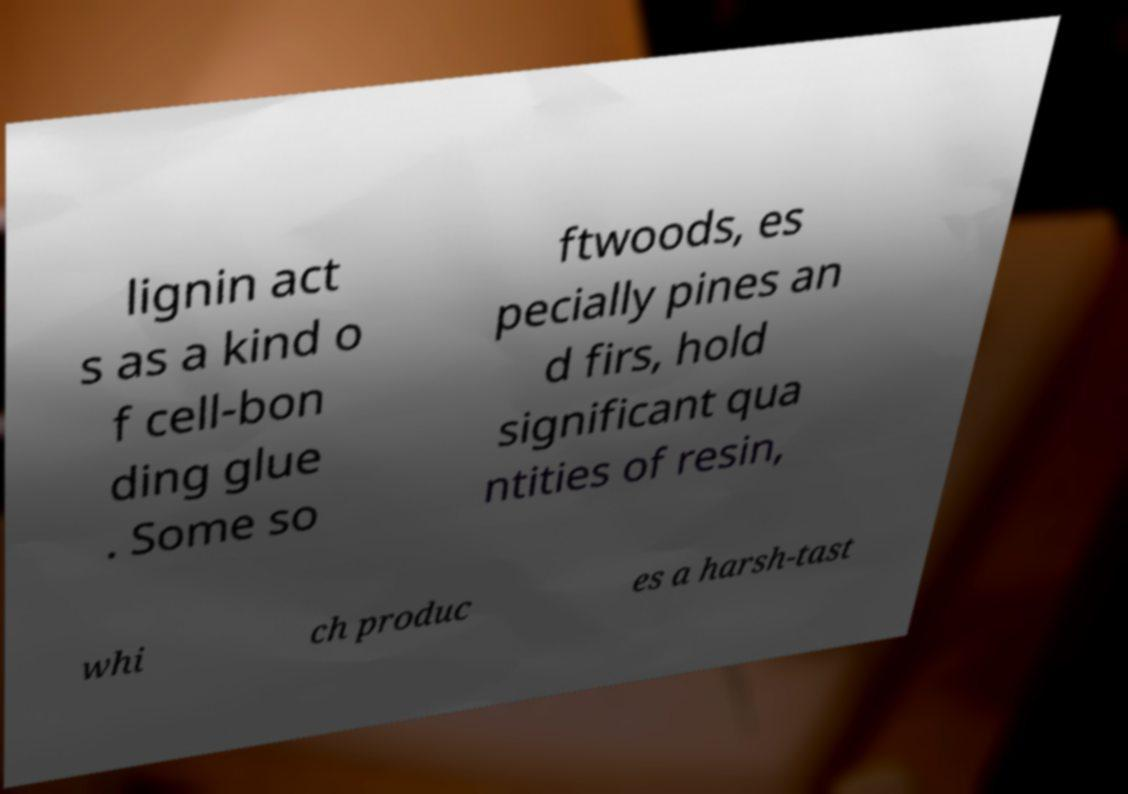Can you read and provide the text displayed in the image?This photo seems to have some interesting text. Can you extract and type it out for me? lignin act s as a kind o f cell-bon ding glue . Some so ftwoods, es pecially pines an d firs, hold significant qua ntities of resin, whi ch produc es a harsh-tast 